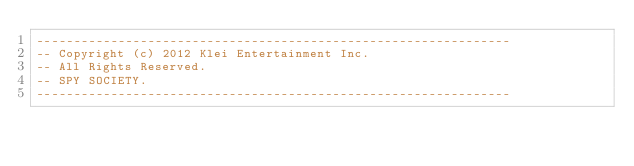<code> <loc_0><loc_0><loc_500><loc_500><_Lua_>----------------------------------------------------------------
-- Copyright (c) 2012 Klei Entertainment Inc.
-- All Rights Reserved.
-- SPY SOCIETY.
----------------------------------------------------------------
</code> 